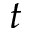Convert formula to latex. <formula><loc_0><loc_0><loc_500><loc_500>t</formula> 